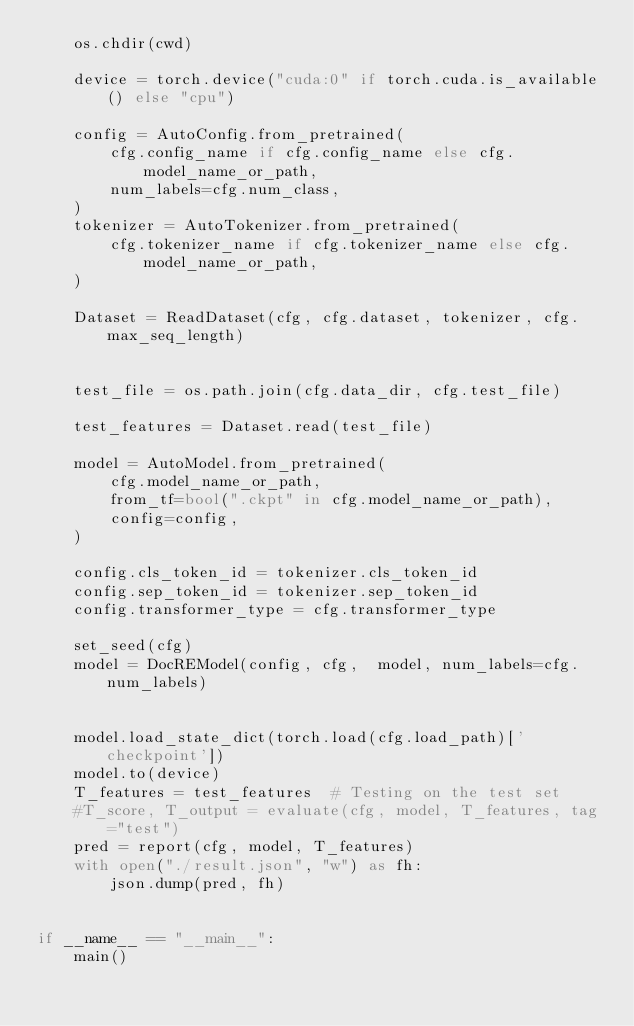<code> <loc_0><loc_0><loc_500><loc_500><_Python_>    os.chdir(cwd)

    device = torch.device("cuda:0" if torch.cuda.is_available() else "cpu")

    config = AutoConfig.from_pretrained(
        cfg.config_name if cfg.config_name else cfg.model_name_or_path,
        num_labels=cfg.num_class,
    )
    tokenizer = AutoTokenizer.from_pretrained(
        cfg.tokenizer_name if cfg.tokenizer_name else cfg.model_name_or_path,
    )

    Dataset = ReadDataset(cfg, cfg.dataset, tokenizer, cfg.max_seq_length)


    test_file = os.path.join(cfg.data_dir, cfg.test_file)

    test_features = Dataset.read(test_file)

    model = AutoModel.from_pretrained(
        cfg.model_name_or_path,
        from_tf=bool(".ckpt" in cfg.model_name_or_path),
        config=config,
    )

    config.cls_token_id = tokenizer.cls_token_id
    config.sep_token_id = tokenizer.sep_token_id
    config.transformer_type = cfg.transformer_type

    set_seed(cfg)
    model = DocREModel(config, cfg,  model, num_labels=cfg.num_labels)


    model.load_state_dict(torch.load(cfg.load_path)['checkpoint'])
    model.to(device)
    T_features = test_features  # Testing on the test set
    #T_score, T_output = evaluate(cfg, model, T_features, tag="test")
    pred = report(cfg, model, T_features)
    with open("./result.json", "w") as fh:
        json.dump(pred, fh)


if __name__ == "__main__":
    main()</code> 